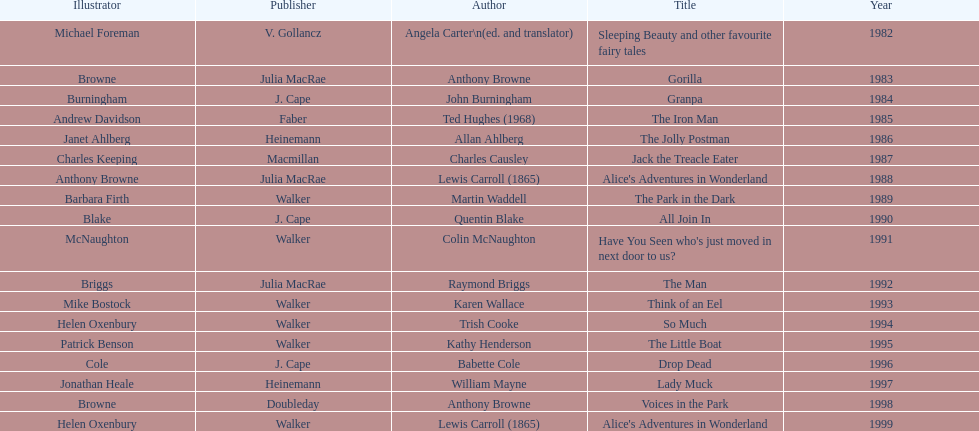How many titles did walker publish? 6. 